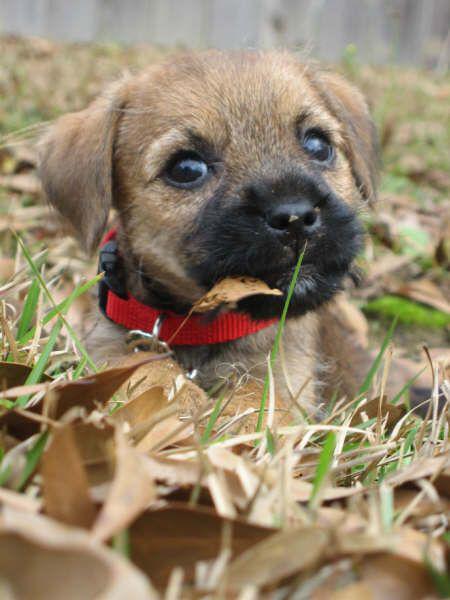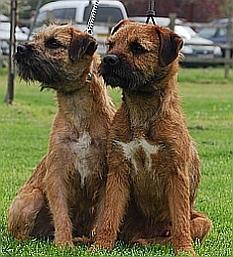The first image is the image on the left, the second image is the image on the right. For the images displayed, is the sentence "There are two dogs" factually correct? Answer yes or no. No. The first image is the image on the left, the second image is the image on the right. Examine the images to the left and right. Is the description "Exactly two small dogs are shown in an outdoor field setting." accurate? Answer yes or no. No. 